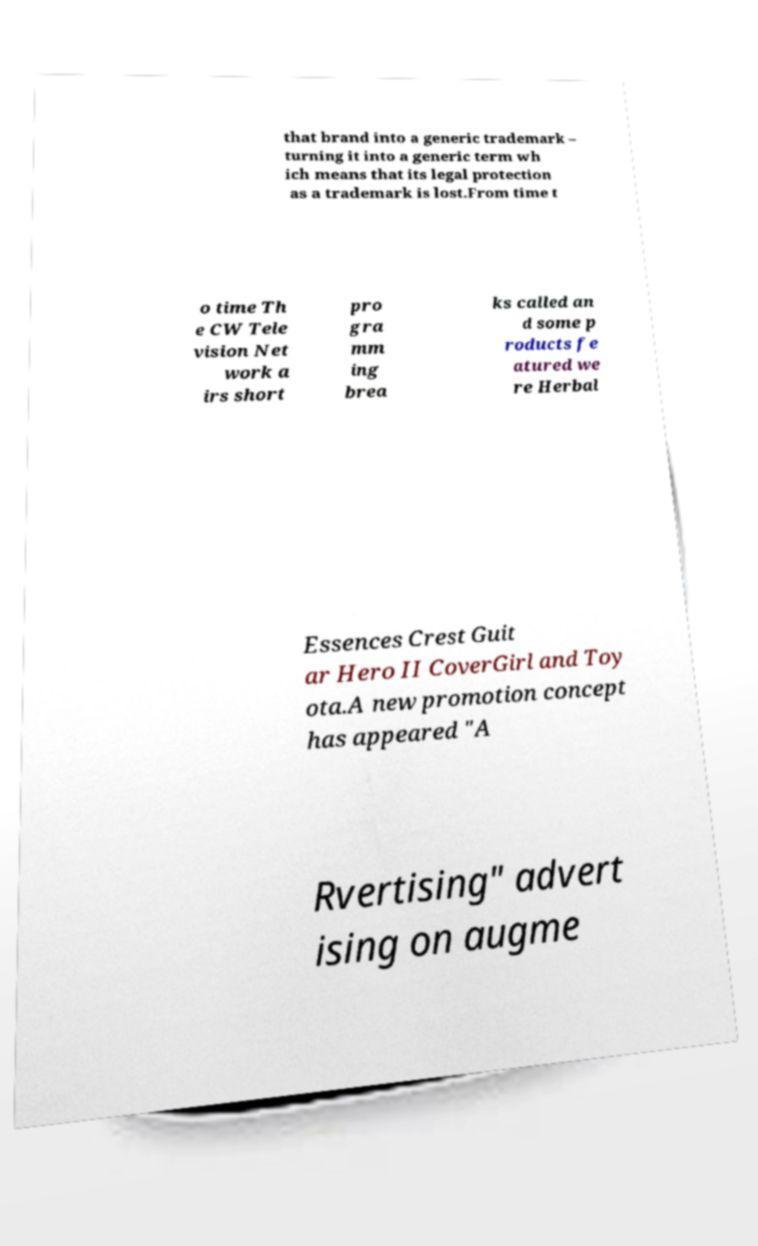Please read and relay the text visible in this image. What does it say? that brand into a generic trademark – turning it into a generic term wh ich means that its legal protection as a trademark is lost.From time t o time Th e CW Tele vision Net work a irs short pro gra mm ing brea ks called an d some p roducts fe atured we re Herbal Essences Crest Guit ar Hero II CoverGirl and Toy ota.A new promotion concept has appeared "A Rvertising" advert ising on augme 